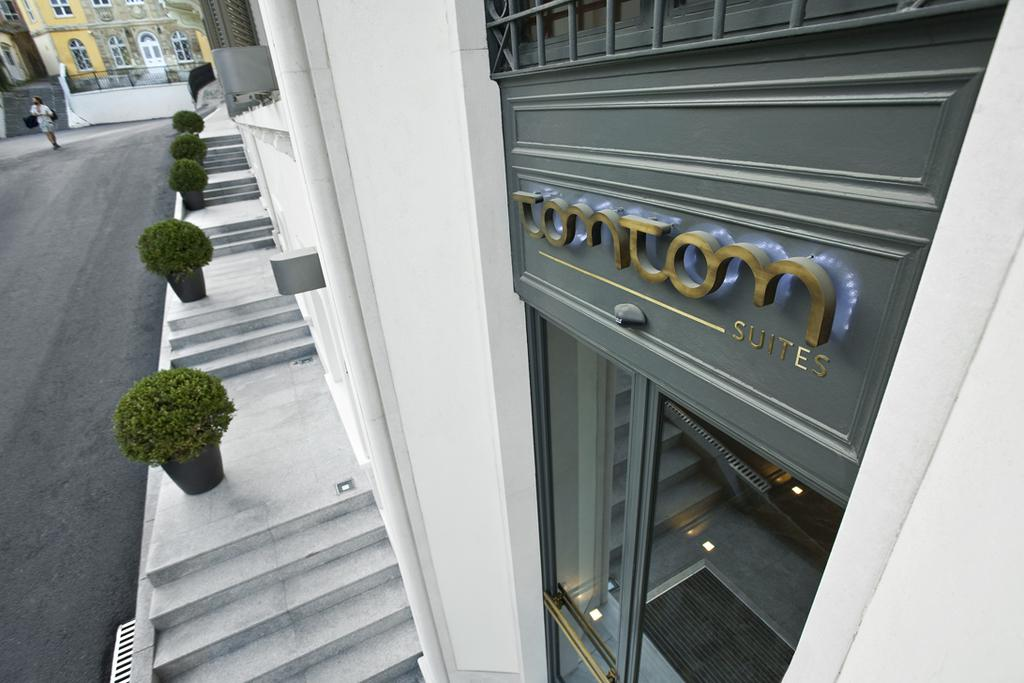Provide a one-sentence caption for the provided image. A SIDEWALK VIEW OF THE TOMTOM SUITES WITH POTTED PLANTERS. 